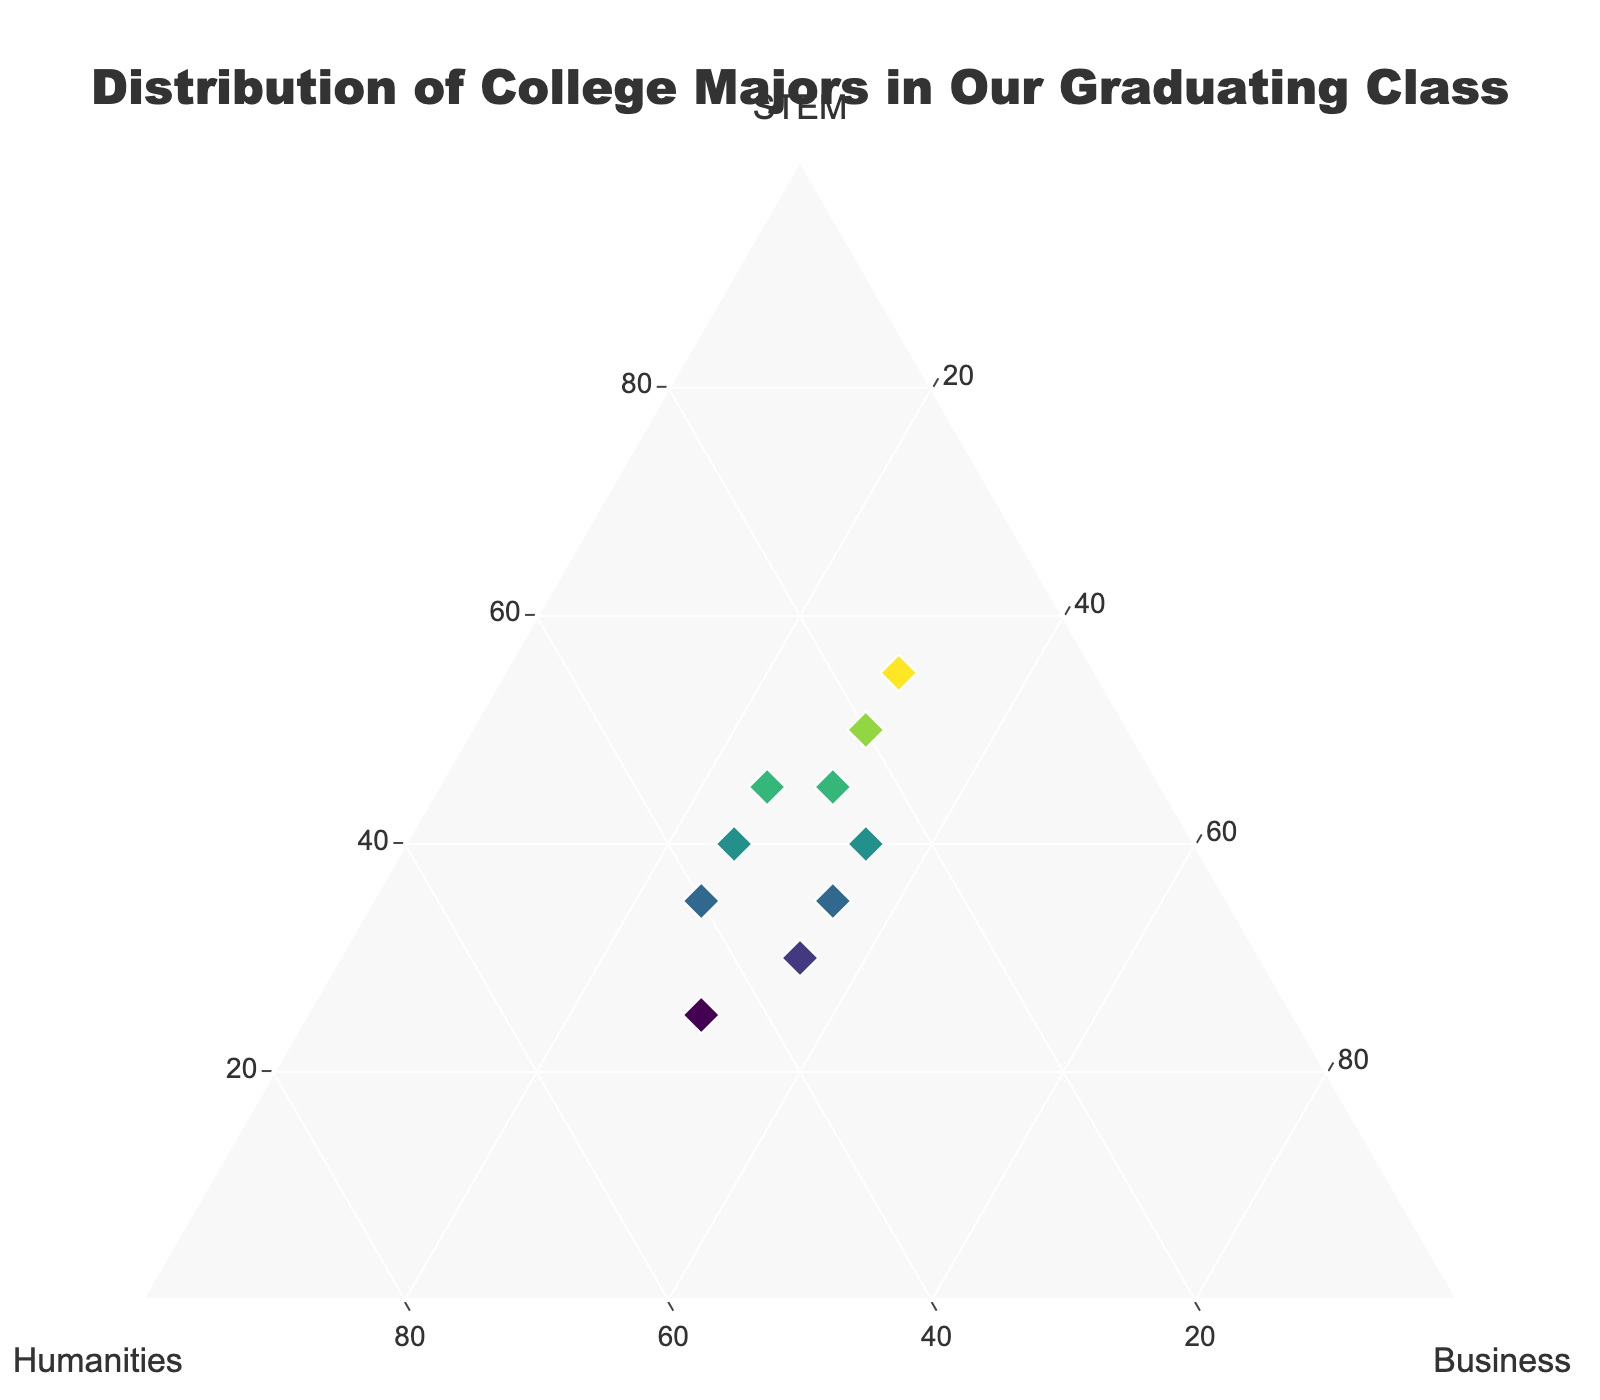What's the title of the ternary plot? The title text is located at the top center of the figure and states the purpose of the plot.
Answer: Distribution of College Majors in Our Graduating Class How many data points are plotted on the ternary plot? By counting the number of markers or 'diamond' symbols within the plot area, we determine the total data points.
Answer: 10 Which major has the highest individual percentage value in any of the data points? The values for each major are displayed as percentages. The highest percentage value is under the STEM category (55%).
Answer: STEM with 55% What's the average percentage of students in STEM across all data points? Sum the STEM percentages (45 + 35 + 40 + 50 + 30 + 55 + 25 + 35 + 45 + 40) and divide by the number of data points (10): (400/10 = 40).
Answer: 40 Compare the first and last data points: Which major has the highest percentage in both cases? First (STEM: 45%, Humanities: 30%, Business: 25%). Last (STEM: 40%, Humanities: 35%, Business: 25%). STEM has the highest percentage in both cases.
Answer: STEM Are there any data points where the percentage of humanities is higher than STEM? Review each data point to identify when the humanities percentage exceeds STEM. Humanities (40) is higher than STEM (35) at the second point, and humanities (45) is higher than STEM (25) at the seventh point.
Answer: Yes What's the minimum percentage for any major across all data points? Searching through all percentages for the smallest value shows Humanities appearing as 15% for one of the points.
Answer: 15% How many data points show an equal percentage for Business and Humanities? Check all points for equality between values in Business and Humanities columns. Two points match this condition: 40, 25, 35 and 35, 30, 35.
Answer: 2 In the data point with the highest STEM percentage, what are the percentages for Humanities and Business? Refer to the data point where STEM is highest (55%). The other percentages here are Humanities (15%) and Business (30%).
Answer: Humanities: 15%, Business: 30% What's the range of percentages for Business majors across all data points? Identifying the maximum and minimum percentages for Business gives 35% (max) - 25% (min).
Answer: 10 